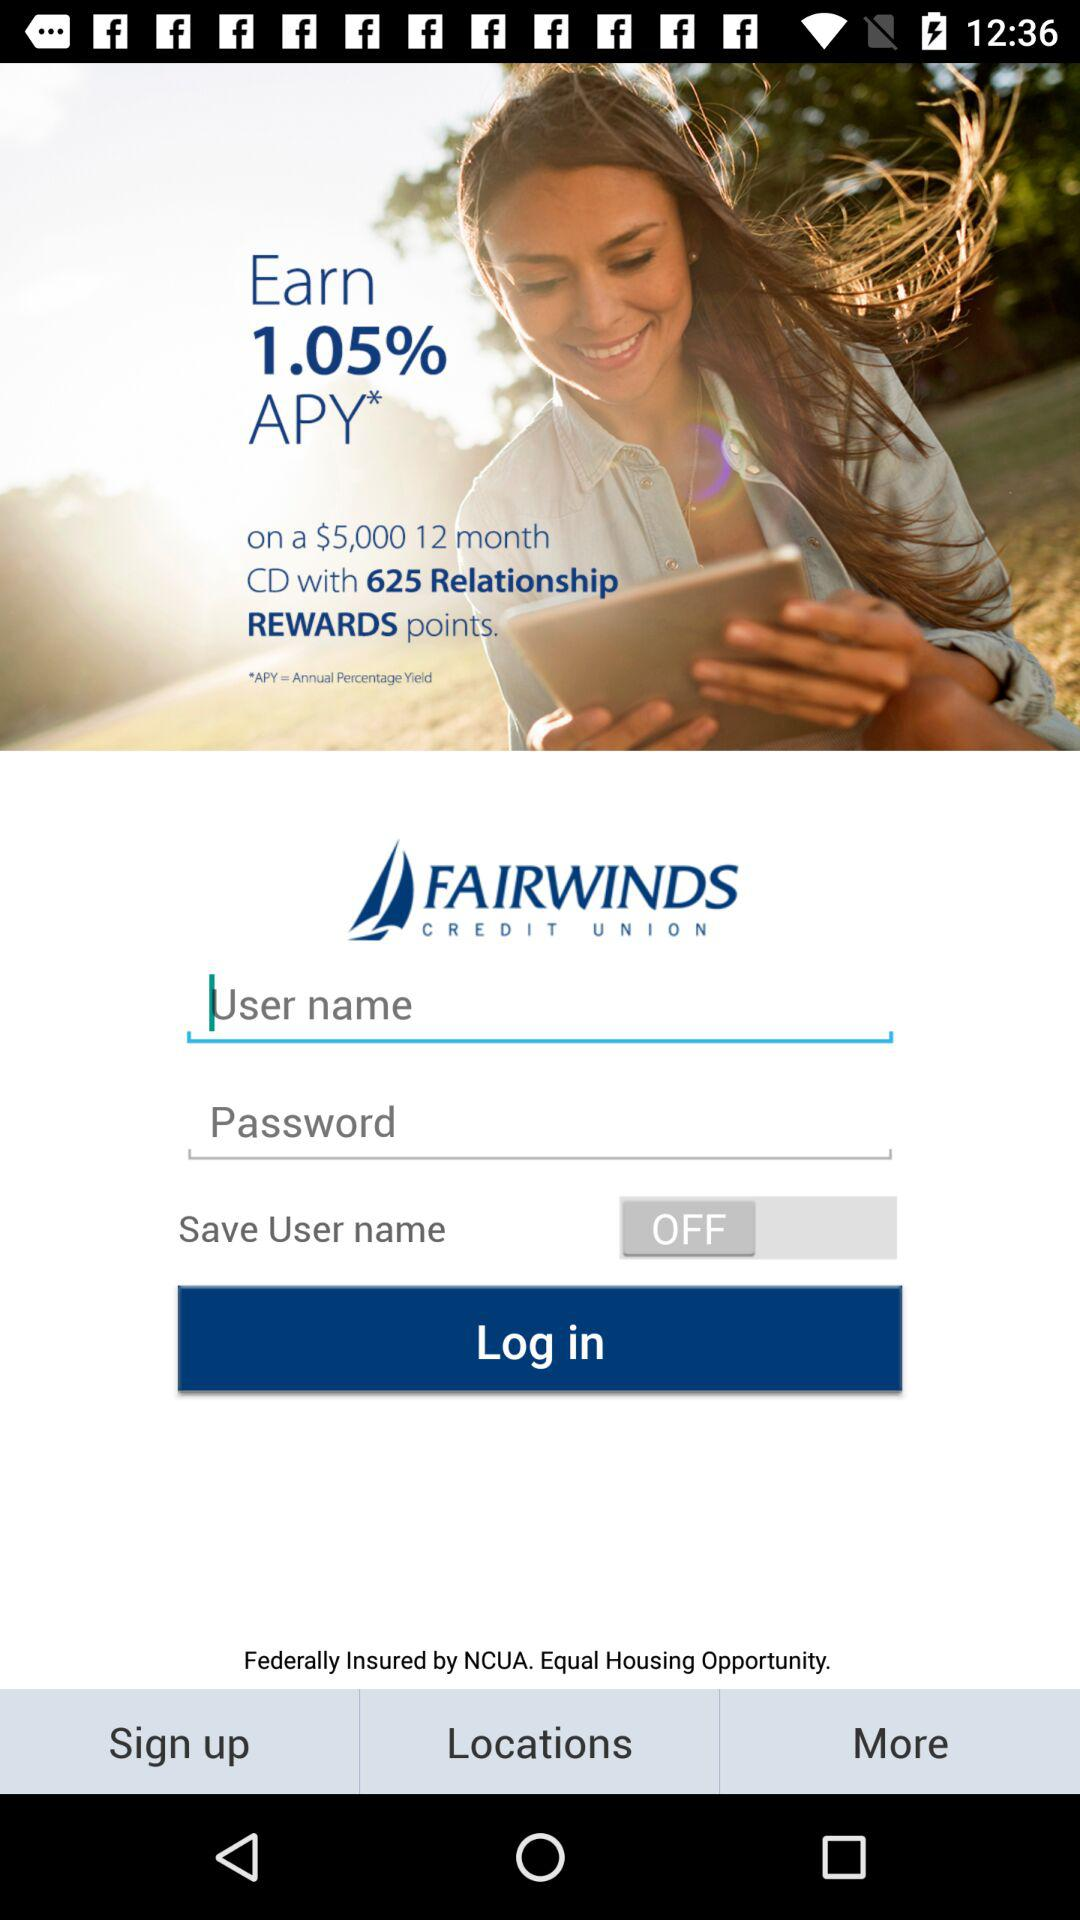How many Relationship REWARDS points are offered for this CD?
Answer the question using a single word or phrase. 625 